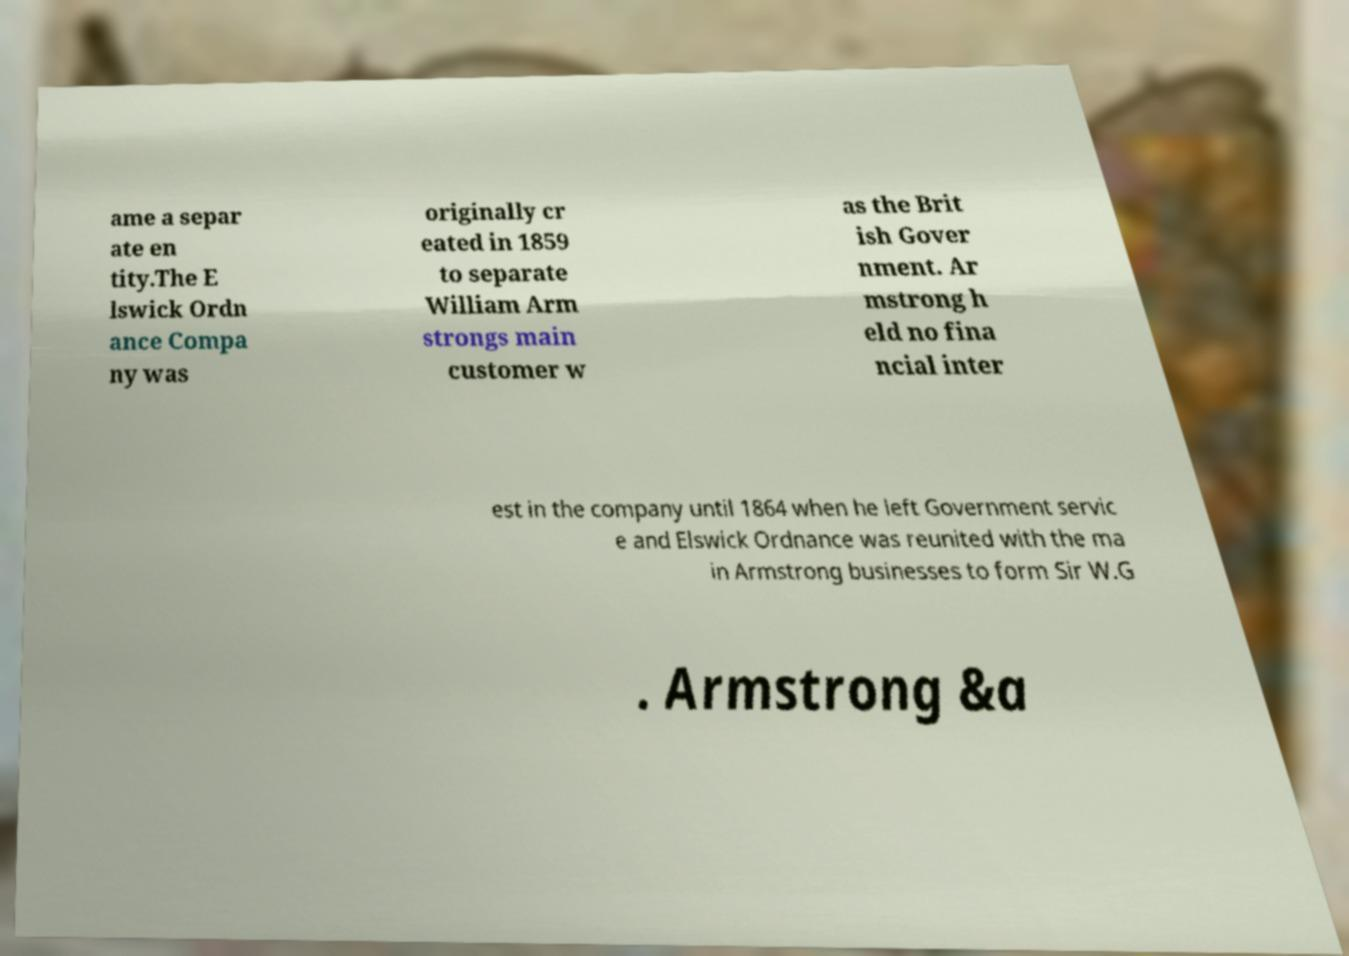I need the written content from this picture converted into text. Can you do that? ame a separ ate en tity.The E lswick Ordn ance Compa ny was originally cr eated in 1859 to separate William Arm strongs main customer w as the Brit ish Gover nment. Ar mstrong h eld no fina ncial inter est in the company until 1864 when he left Government servic e and Elswick Ordnance was reunited with the ma in Armstrong businesses to form Sir W.G . Armstrong &a 